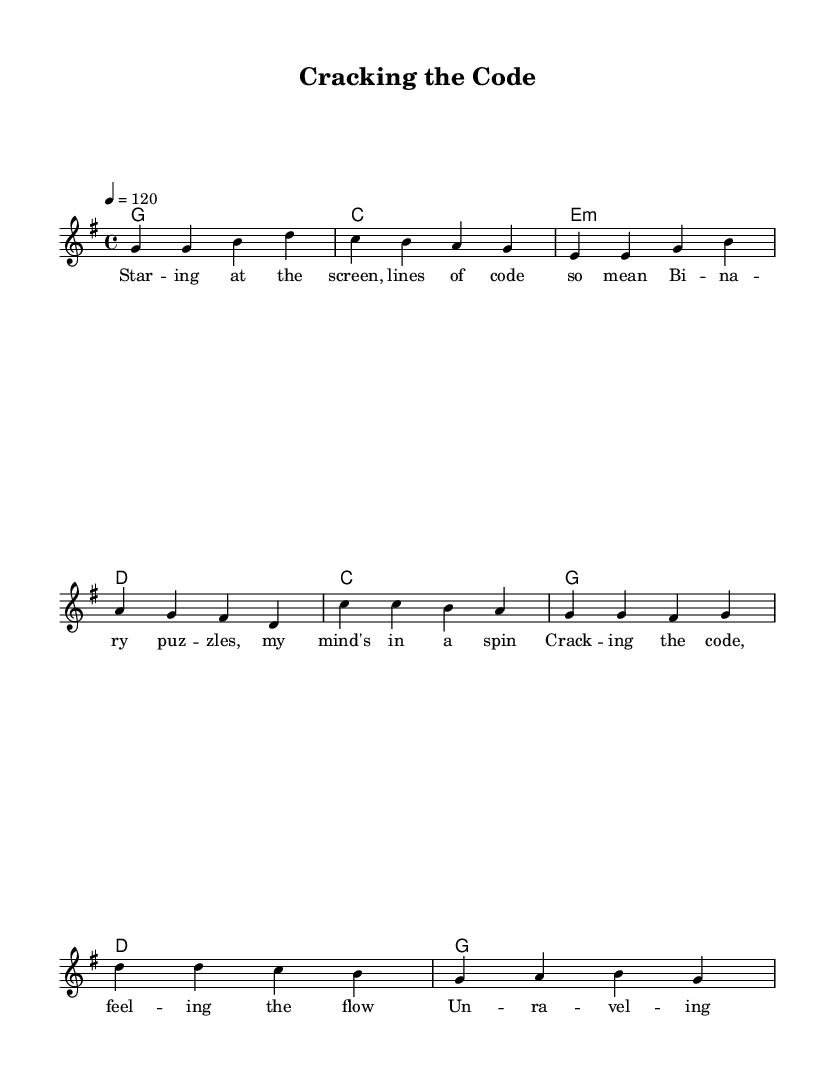what is the key signature of this music? The key signature is G major, which contains one sharp (F#).
Answer: G major what is the time signature of this music? The time signature is 4/4, indicating there are four beats in each measure.
Answer: 4/4 what is the tempo of the piece? The tempo is set at 120 beats per minute, indicated by the marking "4 = 120."
Answer: 120 how many measures are in the verse section? The verse section contains four measures as counted from the melody line.
Answer: 4 which chords are used in the chorus? The chords in the chorus are C, G, D, and G, as specified in the harmonies section.
Answer: C, G, D, G what is the thematic focus of the lyrics? The lyrics focus on cracking code and solving puzzles, suggesting a theme of deciphering complexities.
Answer: Cracking code how does the melody move during the chorus compared to the verse? In the chorus, the melody primarily moves downwards in pitch, while the verse has a more varied upward and downward motion.
Answer: Downwards 